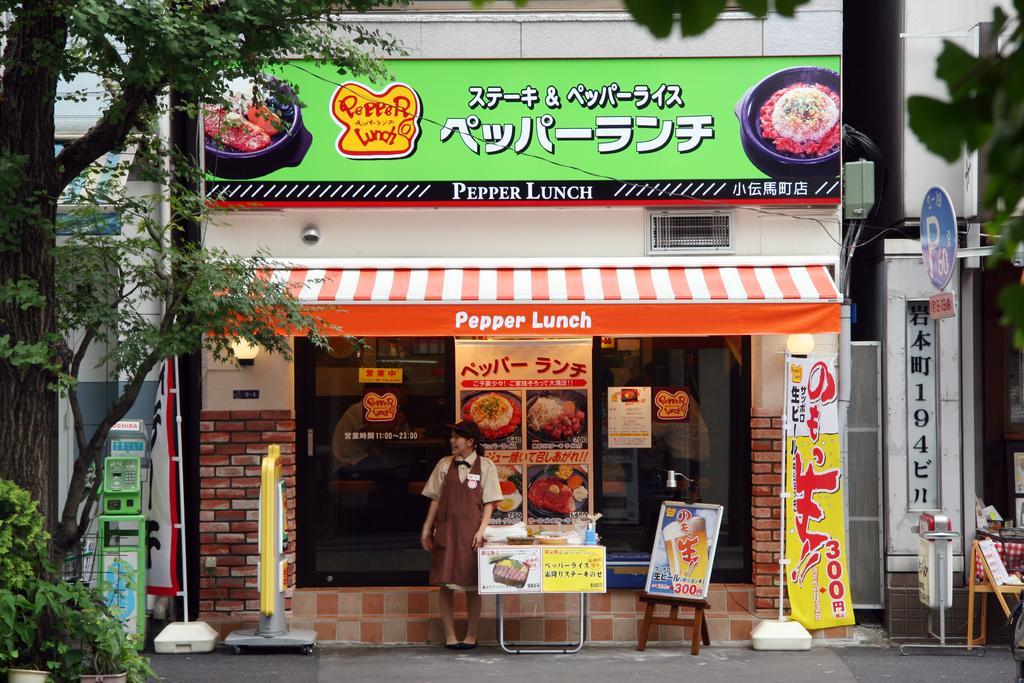Can you describe this image briefly? In this image there are buildings towards the top of the image, there are boards, there is text on the boards, there is a wall, there is a light on the wall, there is a woman standing, there is a table, there are objects on the table, there is road towards the bottom of the image, there are objects on the road, there is a tree towards the left of the image, there are plants towards the left of the image, there are flower pots towards the bottom of the image, there is an object towards the right of the image. 